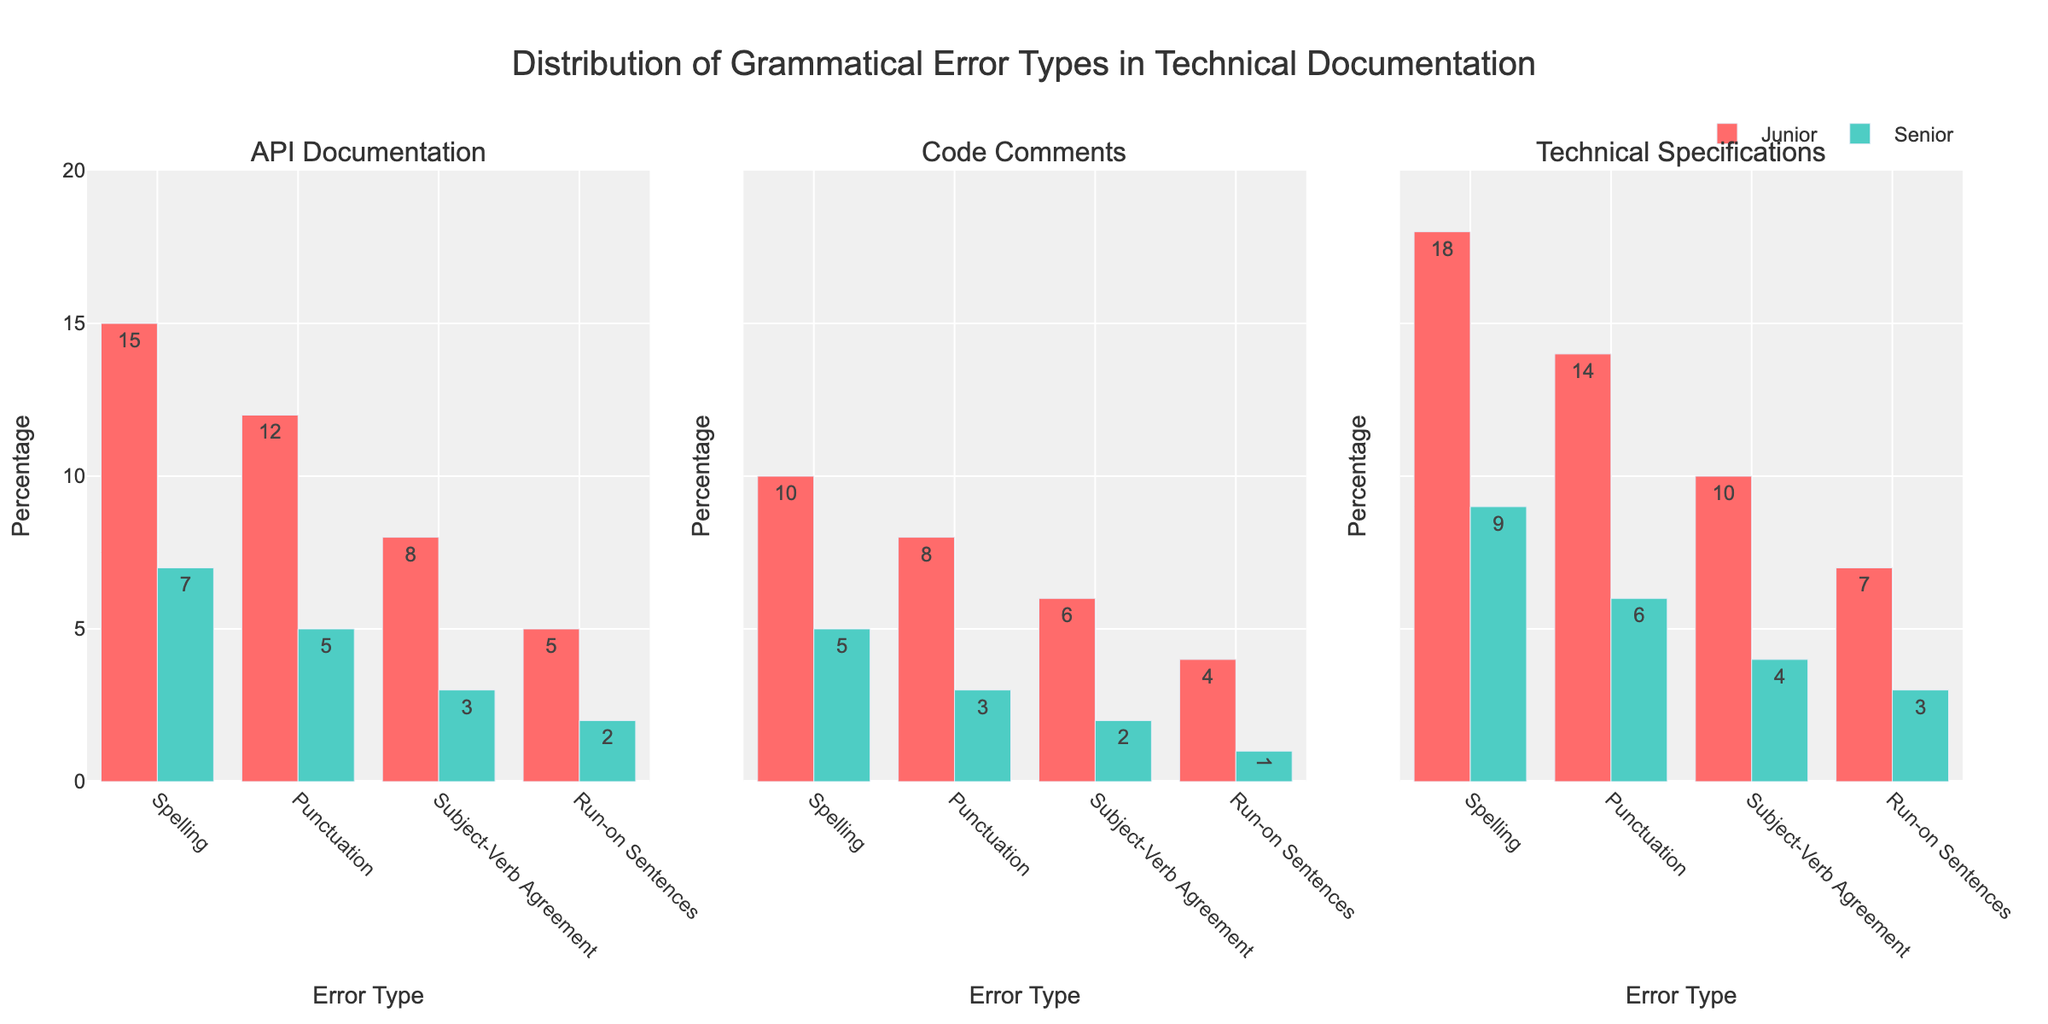What is the title of the figure? The title is located at the top of the figure and reads "Distribution of Grammatical Error Types in Technical Documentation".
Answer: Distribution of Grammatical Error Types in Technical Documentation What color is used for the 'Junior' author experience level? The color for 'Junior' author experience level is used in the bars representing this group across all subplots. The bars are colored in a bright red shade.
Answer: Bright red Which document type has the highest percentage of spelling errors for Junior authors? For Junior authors, you need to compare the heights of the spelling error bars across the three subplots. The Technical Specifications subplot has the tallest spelling error bar.
Answer: Technical Specifications In the API Documentation plot, what is the total combined percentage of punctuation and subject-verb agreement errors for Senior authors? In the API Documentation subplot, for Senior authors, the percentage for punctuation errors is 5, and for subject-verb agreement errors is 3. Adding these together gives 5 + 3 = 8.
Answer: 8 Between Junior and Senior authors, which group has fewer overall grammatical errors in Code Comments? Observe the heights of the bars for both Junior and Senior authors in the Code Comments subplot. Senior authors have noticeably shorter bars across all error types compared to Junior authors.
Answer: Senior authors What is the average percentage of run-on sentence errors across all document types for Junior authors? Examine the run-on sentence error bars for Junior authors across all three subplots: 5 (API Documentation), 4 (Code Comments), and 7 (Technical Specifications). Calculate the average: (5 + 4 + 7) / 3 = 16/3 ≈ 5.33.
Answer: ~5.33 Which error type shows the greatest difference in percentage between Junior and Senior authors in Technical Specifications? In Technical Specifications, compare the differences between Junior and Senior authors for each error type: Spelling (18-9=9), Punctuation (14-6=8), Subject-Verb Agreement (10-4=6), and Run-on Sentences (7-3=4). The greatest difference is for Spelling with a 9% difference.
Answer: Spelling How do the percentages of subject-verb agreement errors in API Documentation compare between Junior and Senior authors? Look at the subject-verb agreement bars in the API Documentation subplot. Junior authors have a percentage of 8, while Senior authors have a percentage of 3. Junior authors have higher subject-verb agreement errors than Senior authors.
Answer: Junior authors have higher What are the combined percentages of all error types for Senior authors in the Code Comments subplot? For Senior authors in the Code Comments subplot, sum the percentages of all error types: Spelling (5), Punctuation (3), Subject-Verb Agreement (2), and Run-on Sentences (1). The total is 5 + 3 + 2 + 1 = 11.
Answer: 11 